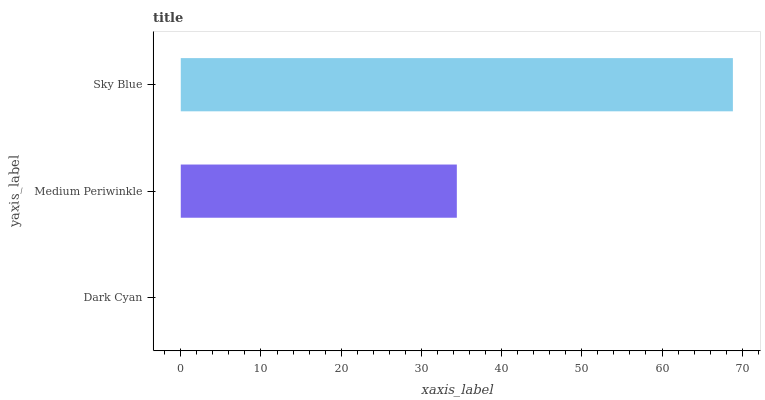Is Dark Cyan the minimum?
Answer yes or no. Yes. Is Sky Blue the maximum?
Answer yes or no. Yes. Is Medium Periwinkle the minimum?
Answer yes or no. No. Is Medium Periwinkle the maximum?
Answer yes or no. No. Is Medium Periwinkle greater than Dark Cyan?
Answer yes or no. Yes. Is Dark Cyan less than Medium Periwinkle?
Answer yes or no. Yes. Is Dark Cyan greater than Medium Periwinkle?
Answer yes or no. No. Is Medium Periwinkle less than Dark Cyan?
Answer yes or no. No. Is Medium Periwinkle the high median?
Answer yes or no. Yes. Is Medium Periwinkle the low median?
Answer yes or no. Yes. Is Dark Cyan the high median?
Answer yes or no. No. Is Sky Blue the low median?
Answer yes or no. No. 